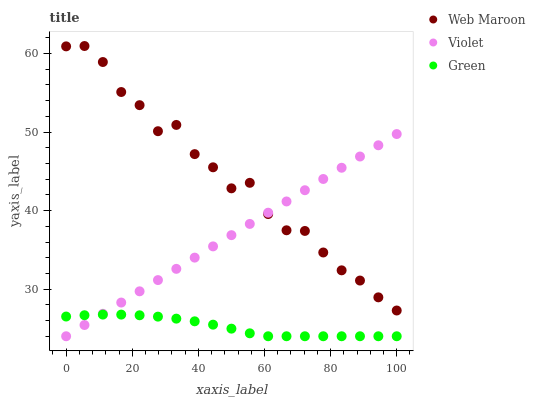Does Green have the minimum area under the curve?
Answer yes or no. Yes. Does Web Maroon have the maximum area under the curve?
Answer yes or no. Yes. Does Violet have the minimum area under the curve?
Answer yes or no. No. Does Violet have the maximum area under the curve?
Answer yes or no. No. Is Violet the smoothest?
Answer yes or no. Yes. Is Web Maroon the roughest?
Answer yes or no. Yes. Is Web Maroon the smoothest?
Answer yes or no. No. Is Violet the roughest?
Answer yes or no. No. Does Green have the lowest value?
Answer yes or no. Yes. Does Web Maroon have the lowest value?
Answer yes or no. No. Does Web Maroon have the highest value?
Answer yes or no. Yes. Does Violet have the highest value?
Answer yes or no. No. Is Green less than Web Maroon?
Answer yes or no. Yes. Is Web Maroon greater than Green?
Answer yes or no. Yes. Does Violet intersect Green?
Answer yes or no. Yes. Is Violet less than Green?
Answer yes or no. No. Is Violet greater than Green?
Answer yes or no. No. Does Green intersect Web Maroon?
Answer yes or no. No. 